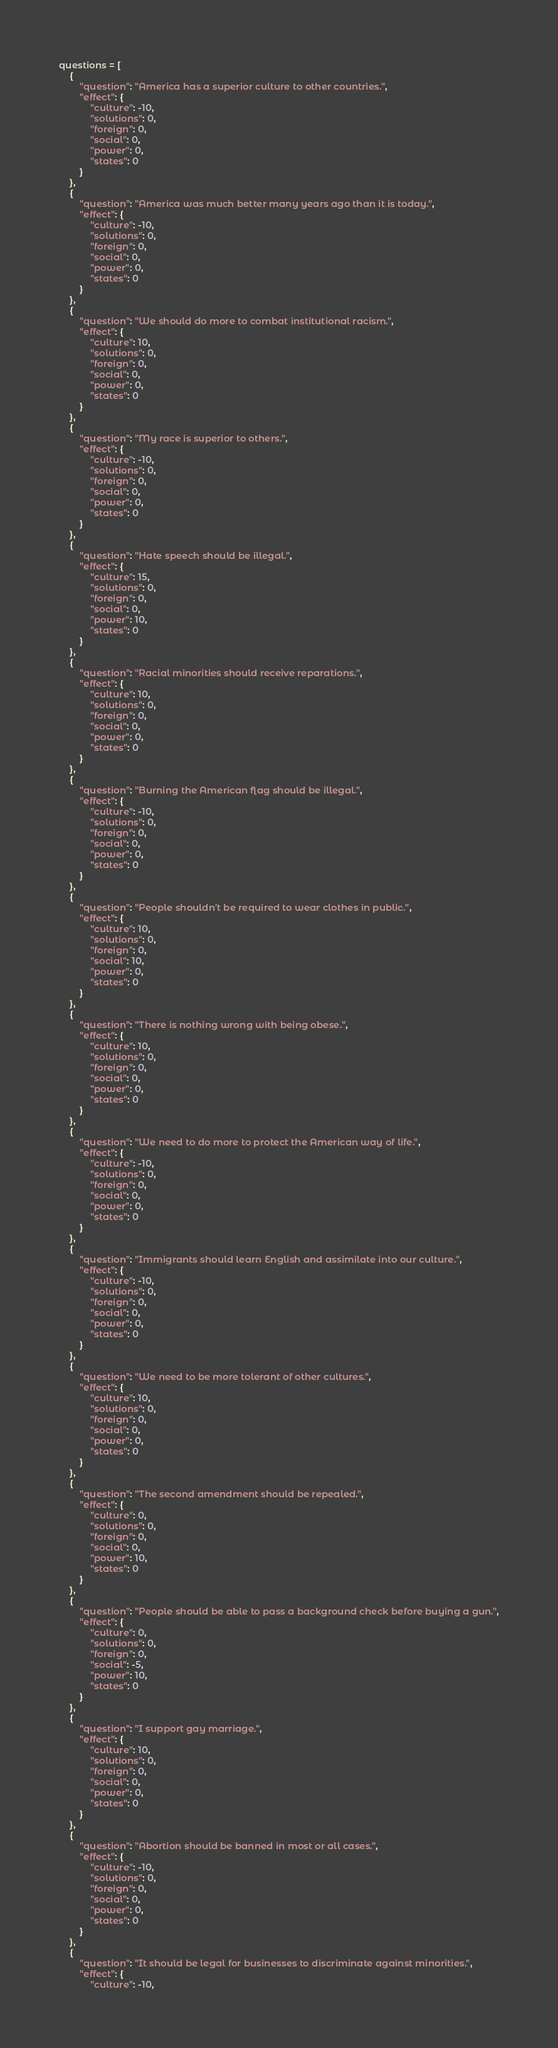<code> <loc_0><loc_0><loc_500><loc_500><_JavaScript_>questions = [
    {
        "question": "America has a superior culture to other countries.",
        "effect": {
            "culture": -10,
            "solutions": 0,
            "foreign": 0,
            "social": 0,
            "power": 0,
            "states": 0
        }
    },
    {
        "question": "America was much better many years ago than it is today.",
        "effect": {
            "culture": -10,
            "solutions": 0,
            "foreign": 0,
            "social": 0,
            "power": 0,
            "states": 0
        }
    },
    {
        "question": "We should do more to combat institutional racism.",
        "effect": {
            "culture": 10,
            "solutions": 0,
            "foreign": 0,
            "social": 0,
            "power": 0,
            "states": 0
        }
    },
    {
        "question": "My race is superior to others.",
        "effect": {
            "culture": -10,
            "solutions": 0,
            "foreign": 0,
            "social": 0,
            "power": 0,
            "states": 0
        }
    },
    {
        "question": "Hate speech should be illegal.",
        "effect": {
            "culture": 15,
            "solutions": 0,
            "foreign": 0,
            "social": 0,
            "power": 10,
            "states": 0
        }
    },
    {
        "question": "Racial minorities should receive reparations.",
        "effect": {
            "culture": 10,
            "solutions": 0,
            "foreign": 0,
            "social": 0,
            "power": 0,
            "states": 0
        }
    },
    {
        "question": "Burning the American flag should be illegal.",
        "effect": {
            "culture": -10,
            "solutions": 0,
            "foreign": 0,
            "social": 0,
            "power": 0,
            "states": 0
        }
    },
    {
        "question": "People shouldn't be required to wear clothes in public.",
        "effect": {
            "culture": 10,
            "solutions": 0,
            "foreign": 0,
            "social": 10,
            "power": 0,
            "states": 0
        }
    },
    {
        "question": "There is nothing wrong with being obese.",
        "effect": {
            "culture": 10,
            "solutions": 0,
            "foreign": 0,
            "social": 0,
            "power": 0,
            "states": 0
        }
    },
    {
        "question": "We need to do more to protect the American way of life.",
        "effect": {
            "culture": -10,
            "solutions": 0,
            "foreign": 0,
            "social": 0,
            "power": 0,
            "states": 0
        }
    },
    {
        "question": "Immigrants should learn English and assimilate into our culture.",
        "effect": {
            "culture": -10,
            "solutions": 0,
            "foreign": 0,
            "social": 0,
            "power": 0,
            "states": 0
        }
    },
    {
        "question": "We need to be more tolerant of other cultures.",
        "effect": {
            "culture": 10,
            "solutions": 0,
            "foreign": 0,
            "social": 0,
            "power": 0,
            "states": 0
        }
    },
    {
        "question": "The second amendment should be repealed.",
        "effect": {
            "culture": 0,
            "solutions": 0,
            "foreign": 0,
            "social": 0,
            "power": 10,
            "states": 0
        }
    },
    {
        "question": "People should be able to pass a background check before buying a gun.",
        "effect": {
            "culture": 0,
            "solutions": 0,
            "foreign": 0,
            "social": -5,
            "power": 10,
            "states": 0
        }
    },
    {
        "question": "I support gay marriage.",
        "effect": {
            "culture": 10,
            "solutions": 0,
            "foreign": 0,
            "social": 0,
            "power": 0,
            "states": 0
        }
    },
    {
        "question": "Abortion should be banned in most or all cases.",
        "effect": {
            "culture": -10,
            "solutions": 0,
            "foreign": 0,
            "social": 0,
            "power": 0,
            "states": 0
        }
    },
    {
        "question": "It should be legal for businesses to discriminate against minorities.",
        "effect": {
            "culture": -10,</code> 